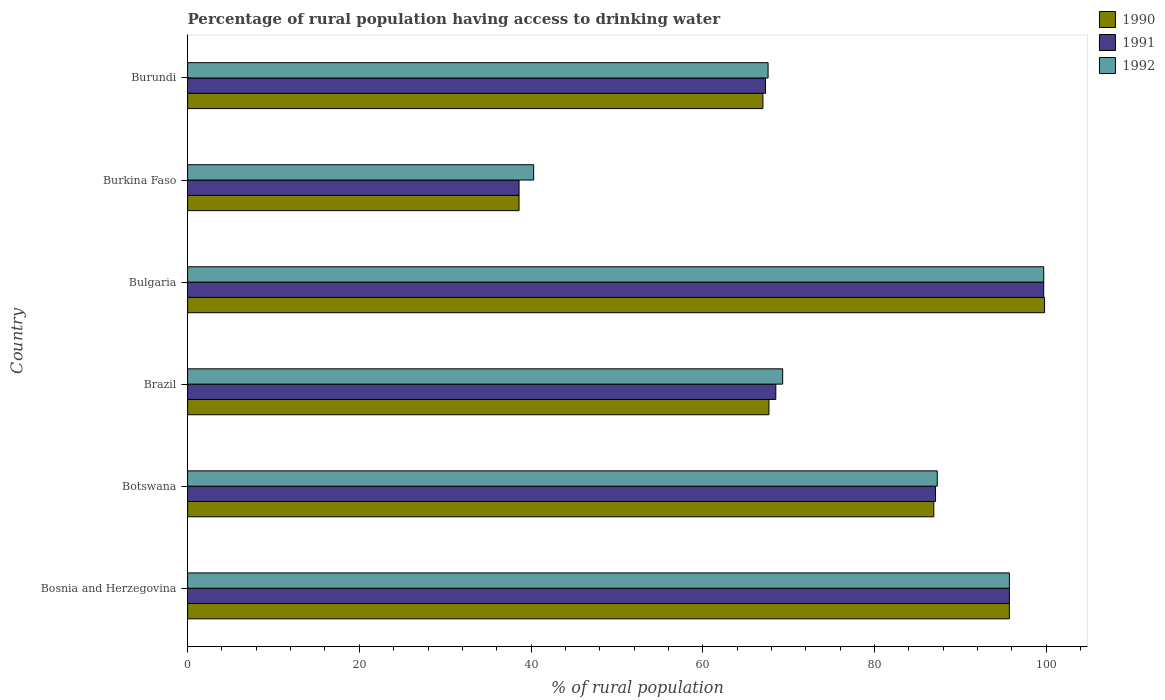How many bars are there on the 2nd tick from the bottom?
Your answer should be very brief. 3. What is the label of the 2nd group of bars from the top?
Ensure brevity in your answer.  Burkina Faso. What is the percentage of rural population having access to drinking water in 1992 in Burundi?
Your answer should be very brief. 67.6. Across all countries, what is the maximum percentage of rural population having access to drinking water in 1992?
Keep it short and to the point. 99.7. Across all countries, what is the minimum percentage of rural population having access to drinking water in 1990?
Ensure brevity in your answer.  38.6. In which country was the percentage of rural population having access to drinking water in 1991 maximum?
Offer a very short reply. Bulgaria. In which country was the percentage of rural population having access to drinking water in 1992 minimum?
Offer a terse response. Burkina Faso. What is the total percentage of rural population having access to drinking water in 1990 in the graph?
Offer a terse response. 455.7. What is the difference between the percentage of rural population having access to drinking water in 1992 in Brazil and that in Burundi?
Offer a very short reply. 1.7. What is the difference between the percentage of rural population having access to drinking water in 1991 in Bosnia and Herzegovina and the percentage of rural population having access to drinking water in 1992 in Botswana?
Offer a very short reply. 8.4. What is the average percentage of rural population having access to drinking water in 1991 per country?
Provide a short and direct response. 76.15. What is the difference between the percentage of rural population having access to drinking water in 1992 and percentage of rural population having access to drinking water in 1991 in Botswana?
Offer a terse response. 0.2. In how many countries, is the percentage of rural population having access to drinking water in 1991 greater than 60 %?
Your answer should be compact. 5. What is the ratio of the percentage of rural population having access to drinking water in 1991 in Botswana to that in Burundi?
Make the answer very short. 1.29. Is the difference between the percentage of rural population having access to drinking water in 1992 in Bosnia and Herzegovina and Bulgaria greater than the difference between the percentage of rural population having access to drinking water in 1991 in Bosnia and Herzegovina and Bulgaria?
Your response must be concise. No. What is the difference between the highest and the lowest percentage of rural population having access to drinking water in 1991?
Your response must be concise. 61.1. In how many countries, is the percentage of rural population having access to drinking water in 1991 greater than the average percentage of rural population having access to drinking water in 1991 taken over all countries?
Your answer should be compact. 3. Is the sum of the percentage of rural population having access to drinking water in 1992 in Bosnia and Herzegovina and Bulgaria greater than the maximum percentage of rural population having access to drinking water in 1990 across all countries?
Your response must be concise. Yes. What does the 3rd bar from the bottom in Bosnia and Herzegovina represents?
Provide a succinct answer. 1992. How many bars are there?
Give a very brief answer. 18. Are all the bars in the graph horizontal?
Keep it short and to the point. Yes. What is the difference between two consecutive major ticks on the X-axis?
Give a very brief answer. 20. Are the values on the major ticks of X-axis written in scientific E-notation?
Your response must be concise. No. What is the title of the graph?
Offer a very short reply. Percentage of rural population having access to drinking water. Does "1976" appear as one of the legend labels in the graph?
Your answer should be compact. No. What is the label or title of the X-axis?
Make the answer very short. % of rural population. What is the label or title of the Y-axis?
Your answer should be very brief. Country. What is the % of rural population in 1990 in Bosnia and Herzegovina?
Offer a very short reply. 95.7. What is the % of rural population in 1991 in Bosnia and Herzegovina?
Make the answer very short. 95.7. What is the % of rural population of 1992 in Bosnia and Herzegovina?
Provide a succinct answer. 95.7. What is the % of rural population in 1990 in Botswana?
Your answer should be very brief. 86.9. What is the % of rural population of 1991 in Botswana?
Your response must be concise. 87.1. What is the % of rural population of 1992 in Botswana?
Your response must be concise. 87.3. What is the % of rural population of 1990 in Brazil?
Provide a short and direct response. 67.7. What is the % of rural population in 1991 in Brazil?
Ensure brevity in your answer.  68.5. What is the % of rural population of 1992 in Brazil?
Offer a terse response. 69.3. What is the % of rural population of 1990 in Bulgaria?
Make the answer very short. 99.8. What is the % of rural population of 1991 in Bulgaria?
Provide a succinct answer. 99.7. What is the % of rural population in 1992 in Bulgaria?
Make the answer very short. 99.7. What is the % of rural population of 1990 in Burkina Faso?
Ensure brevity in your answer.  38.6. What is the % of rural population of 1991 in Burkina Faso?
Provide a succinct answer. 38.6. What is the % of rural population of 1992 in Burkina Faso?
Offer a very short reply. 40.3. What is the % of rural population in 1991 in Burundi?
Your answer should be compact. 67.3. What is the % of rural population of 1992 in Burundi?
Provide a succinct answer. 67.6. Across all countries, what is the maximum % of rural population of 1990?
Offer a very short reply. 99.8. Across all countries, what is the maximum % of rural population of 1991?
Provide a succinct answer. 99.7. Across all countries, what is the maximum % of rural population of 1992?
Give a very brief answer. 99.7. Across all countries, what is the minimum % of rural population in 1990?
Offer a terse response. 38.6. Across all countries, what is the minimum % of rural population in 1991?
Offer a terse response. 38.6. Across all countries, what is the minimum % of rural population of 1992?
Your answer should be compact. 40.3. What is the total % of rural population of 1990 in the graph?
Keep it short and to the point. 455.7. What is the total % of rural population of 1991 in the graph?
Your answer should be compact. 456.9. What is the total % of rural population of 1992 in the graph?
Offer a terse response. 459.9. What is the difference between the % of rural population of 1990 in Bosnia and Herzegovina and that in Brazil?
Give a very brief answer. 28. What is the difference between the % of rural population in 1991 in Bosnia and Herzegovina and that in Brazil?
Provide a short and direct response. 27.2. What is the difference between the % of rural population of 1992 in Bosnia and Herzegovina and that in Brazil?
Ensure brevity in your answer.  26.4. What is the difference between the % of rural population in 1990 in Bosnia and Herzegovina and that in Burkina Faso?
Offer a very short reply. 57.1. What is the difference between the % of rural population of 1991 in Bosnia and Herzegovina and that in Burkina Faso?
Provide a short and direct response. 57.1. What is the difference between the % of rural population of 1992 in Bosnia and Herzegovina and that in Burkina Faso?
Ensure brevity in your answer.  55.4. What is the difference between the % of rural population in 1990 in Bosnia and Herzegovina and that in Burundi?
Ensure brevity in your answer.  28.7. What is the difference between the % of rural population of 1991 in Bosnia and Herzegovina and that in Burundi?
Provide a short and direct response. 28.4. What is the difference between the % of rural population in 1992 in Bosnia and Herzegovina and that in Burundi?
Your answer should be very brief. 28.1. What is the difference between the % of rural population of 1991 in Botswana and that in Brazil?
Offer a very short reply. 18.6. What is the difference between the % of rural population of 1992 in Botswana and that in Brazil?
Keep it short and to the point. 18. What is the difference between the % of rural population of 1991 in Botswana and that in Bulgaria?
Your answer should be compact. -12.6. What is the difference between the % of rural population of 1992 in Botswana and that in Bulgaria?
Give a very brief answer. -12.4. What is the difference between the % of rural population of 1990 in Botswana and that in Burkina Faso?
Make the answer very short. 48.3. What is the difference between the % of rural population in 1991 in Botswana and that in Burkina Faso?
Ensure brevity in your answer.  48.5. What is the difference between the % of rural population in 1992 in Botswana and that in Burkina Faso?
Offer a terse response. 47. What is the difference between the % of rural population of 1990 in Botswana and that in Burundi?
Give a very brief answer. 19.9. What is the difference between the % of rural population in 1991 in Botswana and that in Burundi?
Provide a succinct answer. 19.8. What is the difference between the % of rural population in 1990 in Brazil and that in Bulgaria?
Offer a very short reply. -32.1. What is the difference between the % of rural population of 1991 in Brazil and that in Bulgaria?
Give a very brief answer. -31.2. What is the difference between the % of rural population of 1992 in Brazil and that in Bulgaria?
Your answer should be compact. -30.4. What is the difference between the % of rural population of 1990 in Brazil and that in Burkina Faso?
Your answer should be very brief. 29.1. What is the difference between the % of rural population of 1991 in Brazil and that in Burkina Faso?
Keep it short and to the point. 29.9. What is the difference between the % of rural population of 1991 in Brazil and that in Burundi?
Give a very brief answer. 1.2. What is the difference between the % of rural population of 1990 in Bulgaria and that in Burkina Faso?
Your response must be concise. 61.2. What is the difference between the % of rural population in 1991 in Bulgaria and that in Burkina Faso?
Provide a succinct answer. 61.1. What is the difference between the % of rural population in 1992 in Bulgaria and that in Burkina Faso?
Give a very brief answer. 59.4. What is the difference between the % of rural population in 1990 in Bulgaria and that in Burundi?
Your answer should be compact. 32.8. What is the difference between the % of rural population in 1991 in Bulgaria and that in Burundi?
Your response must be concise. 32.4. What is the difference between the % of rural population of 1992 in Bulgaria and that in Burundi?
Keep it short and to the point. 32.1. What is the difference between the % of rural population in 1990 in Burkina Faso and that in Burundi?
Give a very brief answer. -28.4. What is the difference between the % of rural population in 1991 in Burkina Faso and that in Burundi?
Offer a very short reply. -28.7. What is the difference between the % of rural population in 1992 in Burkina Faso and that in Burundi?
Your answer should be compact. -27.3. What is the difference between the % of rural population in 1990 in Bosnia and Herzegovina and the % of rural population in 1991 in Brazil?
Provide a succinct answer. 27.2. What is the difference between the % of rural population of 1990 in Bosnia and Herzegovina and the % of rural population of 1992 in Brazil?
Your response must be concise. 26.4. What is the difference between the % of rural population in 1991 in Bosnia and Herzegovina and the % of rural population in 1992 in Brazil?
Your answer should be very brief. 26.4. What is the difference between the % of rural population of 1991 in Bosnia and Herzegovina and the % of rural population of 1992 in Bulgaria?
Your answer should be very brief. -4. What is the difference between the % of rural population in 1990 in Bosnia and Herzegovina and the % of rural population in 1991 in Burkina Faso?
Offer a terse response. 57.1. What is the difference between the % of rural population of 1990 in Bosnia and Herzegovina and the % of rural population of 1992 in Burkina Faso?
Your answer should be very brief. 55.4. What is the difference between the % of rural population in 1991 in Bosnia and Herzegovina and the % of rural population in 1992 in Burkina Faso?
Offer a very short reply. 55.4. What is the difference between the % of rural population of 1990 in Bosnia and Herzegovina and the % of rural population of 1991 in Burundi?
Your response must be concise. 28.4. What is the difference between the % of rural population in 1990 in Bosnia and Herzegovina and the % of rural population in 1992 in Burundi?
Make the answer very short. 28.1. What is the difference between the % of rural population of 1991 in Bosnia and Herzegovina and the % of rural population of 1992 in Burundi?
Offer a terse response. 28.1. What is the difference between the % of rural population in 1990 in Botswana and the % of rural population in 1991 in Bulgaria?
Your answer should be compact. -12.8. What is the difference between the % of rural population of 1990 in Botswana and the % of rural population of 1992 in Bulgaria?
Your answer should be compact. -12.8. What is the difference between the % of rural population of 1990 in Botswana and the % of rural population of 1991 in Burkina Faso?
Your answer should be very brief. 48.3. What is the difference between the % of rural population in 1990 in Botswana and the % of rural population in 1992 in Burkina Faso?
Ensure brevity in your answer.  46.6. What is the difference between the % of rural population in 1991 in Botswana and the % of rural population in 1992 in Burkina Faso?
Offer a terse response. 46.8. What is the difference between the % of rural population in 1990 in Botswana and the % of rural population in 1991 in Burundi?
Offer a terse response. 19.6. What is the difference between the % of rural population in 1990 in Botswana and the % of rural population in 1992 in Burundi?
Your answer should be compact. 19.3. What is the difference between the % of rural population in 1990 in Brazil and the % of rural population in 1991 in Bulgaria?
Offer a terse response. -32. What is the difference between the % of rural population in 1990 in Brazil and the % of rural population in 1992 in Bulgaria?
Provide a succinct answer. -32. What is the difference between the % of rural population of 1991 in Brazil and the % of rural population of 1992 in Bulgaria?
Give a very brief answer. -31.2. What is the difference between the % of rural population in 1990 in Brazil and the % of rural population in 1991 in Burkina Faso?
Make the answer very short. 29.1. What is the difference between the % of rural population of 1990 in Brazil and the % of rural population of 1992 in Burkina Faso?
Give a very brief answer. 27.4. What is the difference between the % of rural population of 1991 in Brazil and the % of rural population of 1992 in Burkina Faso?
Provide a succinct answer. 28.2. What is the difference between the % of rural population of 1990 in Brazil and the % of rural population of 1992 in Burundi?
Ensure brevity in your answer.  0.1. What is the difference between the % of rural population of 1991 in Brazil and the % of rural population of 1992 in Burundi?
Provide a short and direct response. 0.9. What is the difference between the % of rural population of 1990 in Bulgaria and the % of rural population of 1991 in Burkina Faso?
Offer a very short reply. 61.2. What is the difference between the % of rural population in 1990 in Bulgaria and the % of rural population in 1992 in Burkina Faso?
Provide a succinct answer. 59.5. What is the difference between the % of rural population of 1991 in Bulgaria and the % of rural population of 1992 in Burkina Faso?
Provide a succinct answer. 59.4. What is the difference between the % of rural population of 1990 in Bulgaria and the % of rural population of 1991 in Burundi?
Your answer should be very brief. 32.5. What is the difference between the % of rural population of 1990 in Bulgaria and the % of rural population of 1992 in Burundi?
Provide a short and direct response. 32.2. What is the difference between the % of rural population in 1991 in Bulgaria and the % of rural population in 1992 in Burundi?
Provide a succinct answer. 32.1. What is the difference between the % of rural population of 1990 in Burkina Faso and the % of rural population of 1991 in Burundi?
Provide a short and direct response. -28.7. What is the difference between the % of rural population of 1990 in Burkina Faso and the % of rural population of 1992 in Burundi?
Give a very brief answer. -29. What is the difference between the % of rural population in 1991 in Burkina Faso and the % of rural population in 1992 in Burundi?
Offer a very short reply. -29. What is the average % of rural population in 1990 per country?
Ensure brevity in your answer.  75.95. What is the average % of rural population of 1991 per country?
Your answer should be very brief. 76.15. What is the average % of rural population in 1992 per country?
Offer a terse response. 76.65. What is the difference between the % of rural population of 1990 and % of rural population of 1992 in Bosnia and Herzegovina?
Your answer should be very brief. 0. What is the difference between the % of rural population in 1990 and % of rural population in 1991 in Botswana?
Keep it short and to the point. -0.2. What is the difference between the % of rural population in 1990 and % of rural population in 1992 in Botswana?
Keep it short and to the point. -0.4. What is the difference between the % of rural population of 1991 and % of rural population of 1992 in Botswana?
Provide a short and direct response. -0.2. What is the difference between the % of rural population in 1990 and % of rural population in 1992 in Brazil?
Provide a succinct answer. -1.6. What is the difference between the % of rural population of 1991 and % of rural population of 1992 in Brazil?
Provide a short and direct response. -0.8. What is the difference between the % of rural population in 1990 and % of rural population in 1991 in Bulgaria?
Your answer should be compact. 0.1. What is the difference between the % of rural population of 1990 and % of rural population of 1992 in Bulgaria?
Your response must be concise. 0.1. What is the difference between the % of rural population of 1991 and % of rural population of 1992 in Bulgaria?
Offer a very short reply. 0. What is the difference between the % of rural population in 1990 and % of rural population in 1992 in Burkina Faso?
Provide a succinct answer. -1.7. What is the difference between the % of rural population of 1991 and % of rural population of 1992 in Burundi?
Offer a very short reply. -0.3. What is the ratio of the % of rural population in 1990 in Bosnia and Herzegovina to that in Botswana?
Offer a very short reply. 1.1. What is the ratio of the % of rural population in 1991 in Bosnia and Herzegovina to that in Botswana?
Give a very brief answer. 1.1. What is the ratio of the % of rural population of 1992 in Bosnia and Herzegovina to that in Botswana?
Provide a succinct answer. 1.1. What is the ratio of the % of rural population in 1990 in Bosnia and Herzegovina to that in Brazil?
Ensure brevity in your answer.  1.41. What is the ratio of the % of rural population of 1991 in Bosnia and Herzegovina to that in Brazil?
Keep it short and to the point. 1.4. What is the ratio of the % of rural population of 1992 in Bosnia and Herzegovina to that in Brazil?
Offer a terse response. 1.38. What is the ratio of the % of rural population in 1990 in Bosnia and Herzegovina to that in Bulgaria?
Offer a very short reply. 0.96. What is the ratio of the % of rural population in 1991 in Bosnia and Herzegovina to that in Bulgaria?
Give a very brief answer. 0.96. What is the ratio of the % of rural population in 1992 in Bosnia and Herzegovina to that in Bulgaria?
Your answer should be very brief. 0.96. What is the ratio of the % of rural population of 1990 in Bosnia and Herzegovina to that in Burkina Faso?
Give a very brief answer. 2.48. What is the ratio of the % of rural population in 1991 in Bosnia and Herzegovina to that in Burkina Faso?
Provide a succinct answer. 2.48. What is the ratio of the % of rural population of 1992 in Bosnia and Herzegovina to that in Burkina Faso?
Offer a terse response. 2.37. What is the ratio of the % of rural population in 1990 in Bosnia and Herzegovina to that in Burundi?
Provide a short and direct response. 1.43. What is the ratio of the % of rural population in 1991 in Bosnia and Herzegovina to that in Burundi?
Your answer should be compact. 1.42. What is the ratio of the % of rural population of 1992 in Bosnia and Herzegovina to that in Burundi?
Offer a terse response. 1.42. What is the ratio of the % of rural population of 1990 in Botswana to that in Brazil?
Your response must be concise. 1.28. What is the ratio of the % of rural population of 1991 in Botswana to that in Brazil?
Your answer should be very brief. 1.27. What is the ratio of the % of rural population of 1992 in Botswana to that in Brazil?
Ensure brevity in your answer.  1.26. What is the ratio of the % of rural population of 1990 in Botswana to that in Bulgaria?
Your response must be concise. 0.87. What is the ratio of the % of rural population of 1991 in Botswana to that in Bulgaria?
Offer a terse response. 0.87. What is the ratio of the % of rural population of 1992 in Botswana to that in Bulgaria?
Provide a short and direct response. 0.88. What is the ratio of the % of rural population of 1990 in Botswana to that in Burkina Faso?
Your response must be concise. 2.25. What is the ratio of the % of rural population in 1991 in Botswana to that in Burkina Faso?
Provide a succinct answer. 2.26. What is the ratio of the % of rural population in 1992 in Botswana to that in Burkina Faso?
Ensure brevity in your answer.  2.17. What is the ratio of the % of rural population in 1990 in Botswana to that in Burundi?
Your response must be concise. 1.3. What is the ratio of the % of rural population in 1991 in Botswana to that in Burundi?
Offer a very short reply. 1.29. What is the ratio of the % of rural population in 1992 in Botswana to that in Burundi?
Your response must be concise. 1.29. What is the ratio of the % of rural population in 1990 in Brazil to that in Bulgaria?
Provide a succinct answer. 0.68. What is the ratio of the % of rural population in 1991 in Brazil to that in Bulgaria?
Provide a short and direct response. 0.69. What is the ratio of the % of rural population of 1992 in Brazil to that in Bulgaria?
Give a very brief answer. 0.7. What is the ratio of the % of rural population in 1990 in Brazil to that in Burkina Faso?
Your answer should be very brief. 1.75. What is the ratio of the % of rural population in 1991 in Brazil to that in Burkina Faso?
Ensure brevity in your answer.  1.77. What is the ratio of the % of rural population in 1992 in Brazil to that in Burkina Faso?
Your response must be concise. 1.72. What is the ratio of the % of rural population of 1990 in Brazil to that in Burundi?
Give a very brief answer. 1.01. What is the ratio of the % of rural population of 1991 in Brazil to that in Burundi?
Offer a terse response. 1.02. What is the ratio of the % of rural population in 1992 in Brazil to that in Burundi?
Your response must be concise. 1.03. What is the ratio of the % of rural population of 1990 in Bulgaria to that in Burkina Faso?
Your answer should be compact. 2.59. What is the ratio of the % of rural population in 1991 in Bulgaria to that in Burkina Faso?
Your answer should be compact. 2.58. What is the ratio of the % of rural population in 1992 in Bulgaria to that in Burkina Faso?
Ensure brevity in your answer.  2.47. What is the ratio of the % of rural population in 1990 in Bulgaria to that in Burundi?
Provide a succinct answer. 1.49. What is the ratio of the % of rural population of 1991 in Bulgaria to that in Burundi?
Ensure brevity in your answer.  1.48. What is the ratio of the % of rural population in 1992 in Bulgaria to that in Burundi?
Provide a short and direct response. 1.47. What is the ratio of the % of rural population of 1990 in Burkina Faso to that in Burundi?
Your answer should be compact. 0.58. What is the ratio of the % of rural population in 1991 in Burkina Faso to that in Burundi?
Offer a terse response. 0.57. What is the ratio of the % of rural population in 1992 in Burkina Faso to that in Burundi?
Your response must be concise. 0.6. What is the difference between the highest and the second highest % of rural population in 1990?
Offer a very short reply. 4.1. What is the difference between the highest and the second highest % of rural population of 1991?
Offer a terse response. 4. What is the difference between the highest and the lowest % of rural population in 1990?
Ensure brevity in your answer.  61.2. What is the difference between the highest and the lowest % of rural population in 1991?
Your response must be concise. 61.1. What is the difference between the highest and the lowest % of rural population of 1992?
Your response must be concise. 59.4. 